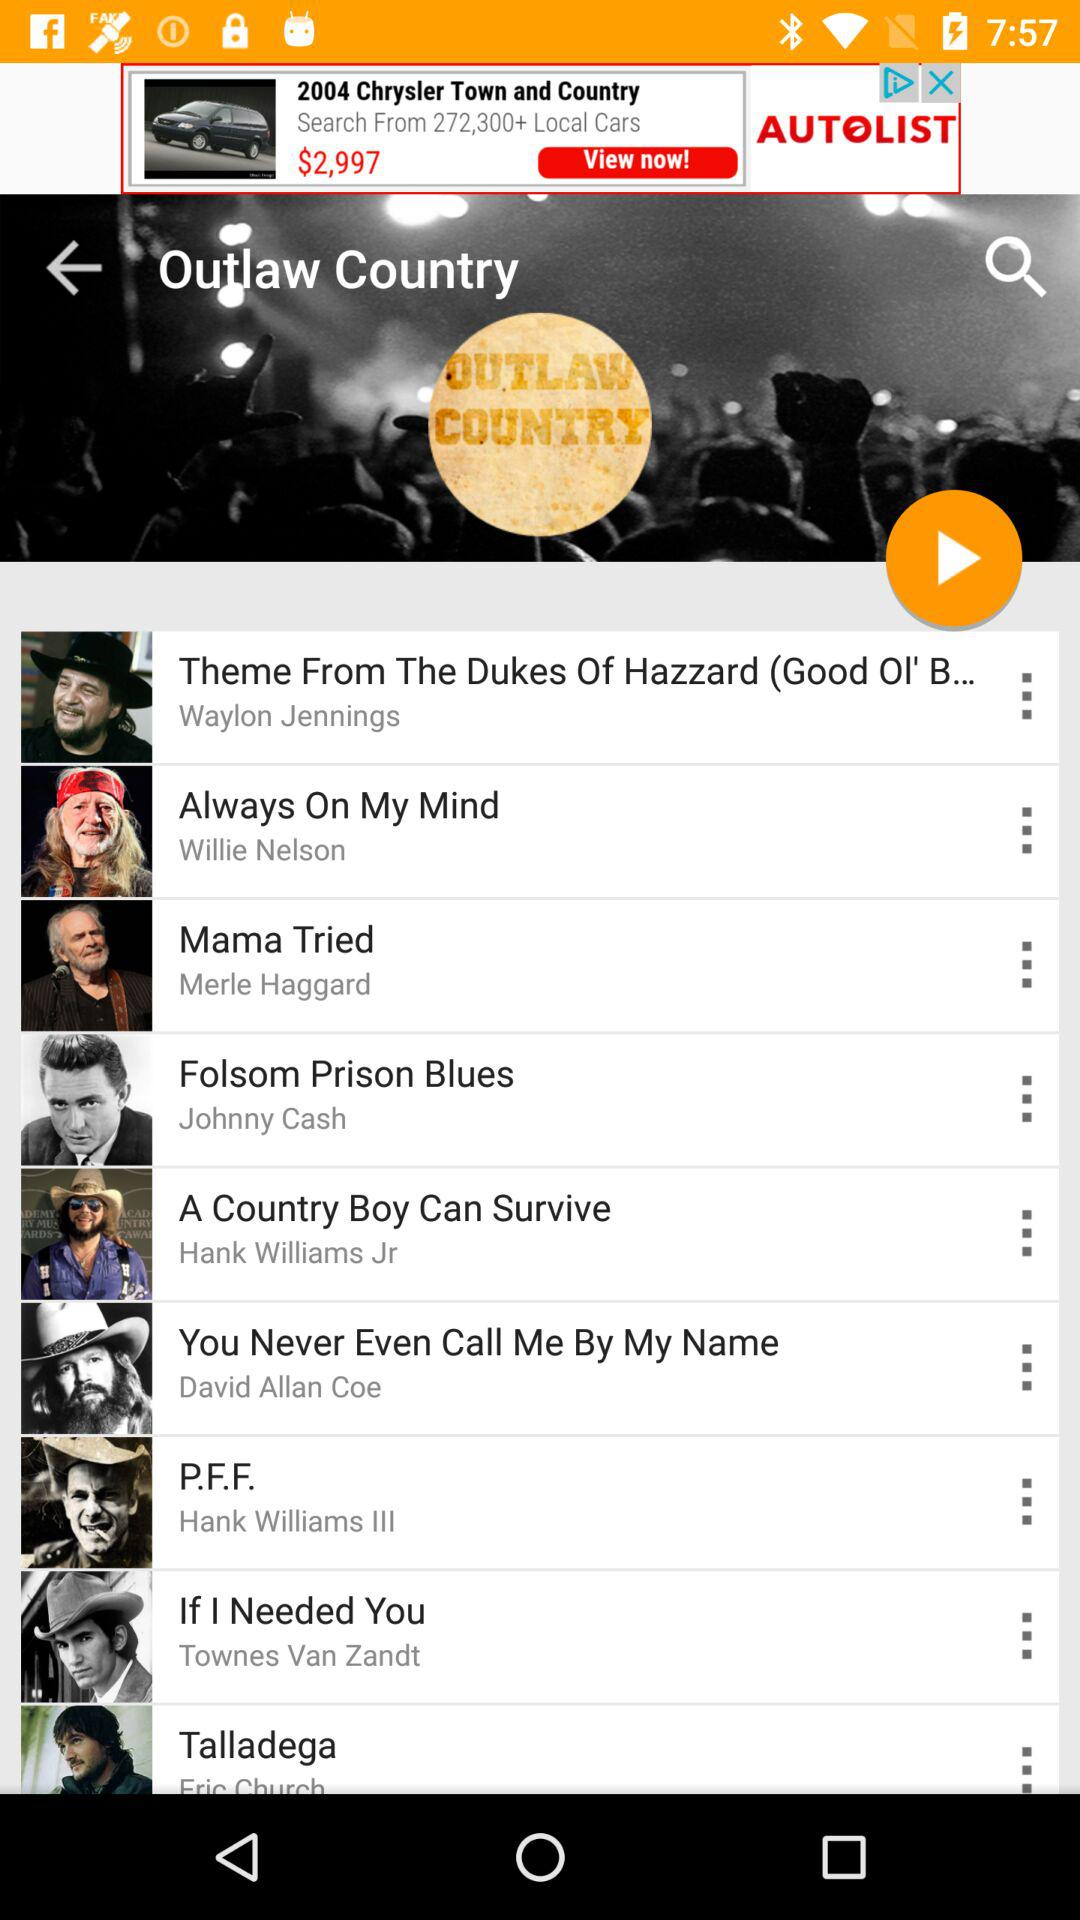Which song's artist is Johnny Cash? Johnny Cash is the artist of the song "Folsom Prison Blues". 